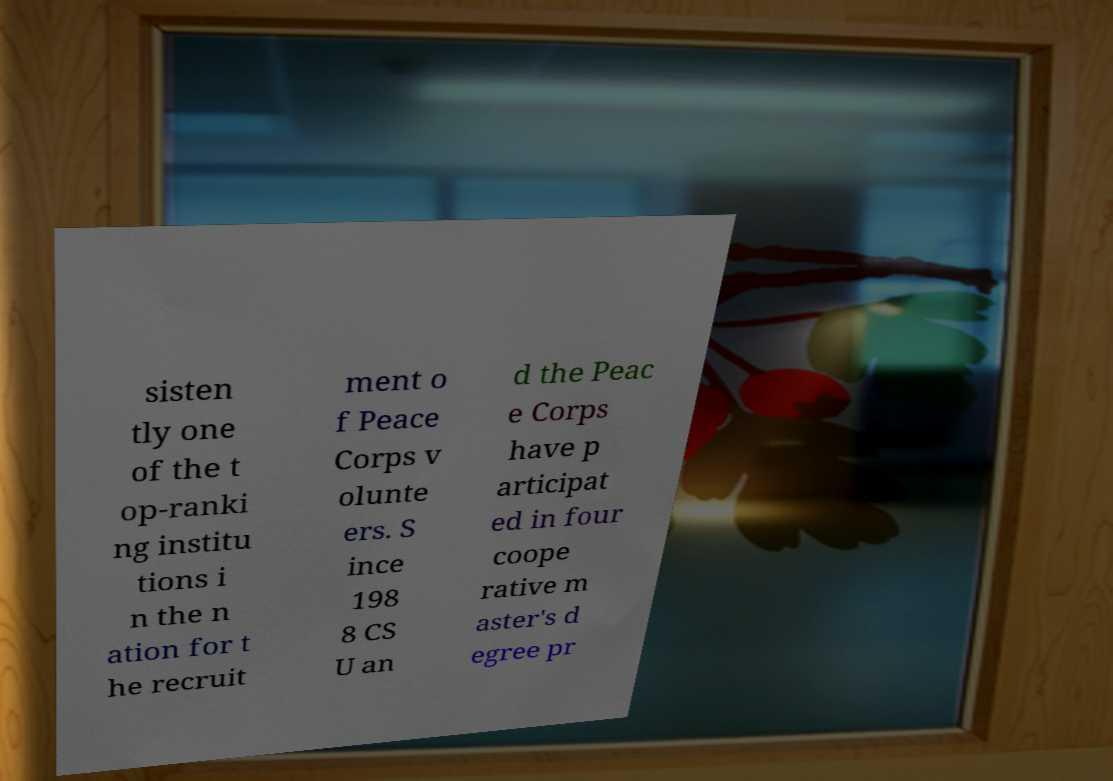Could you assist in decoding the text presented in this image and type it out clearly? sisten tly one of the t op-ranki ng institu tions i n the n ation for t he recruit ment o f Peace Corps v olunte ers. S ince 198 8 CS U an d the Peac e Corps have p articipat ed in four coope rative m aster's d egree pr 